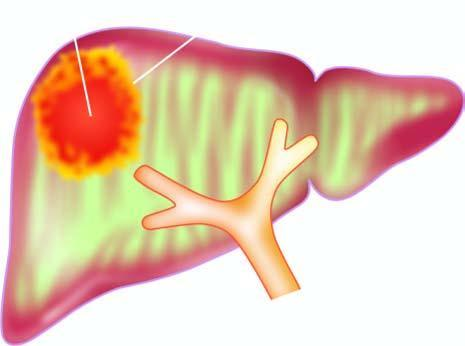s moebic liver abscess commonly solitary?
Answer the question using a single word or phrase. Yes 